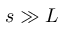Convert formula to latex. <formula><loc_0><loc_0><loc_500><loc_500>s \gg L</formula> 